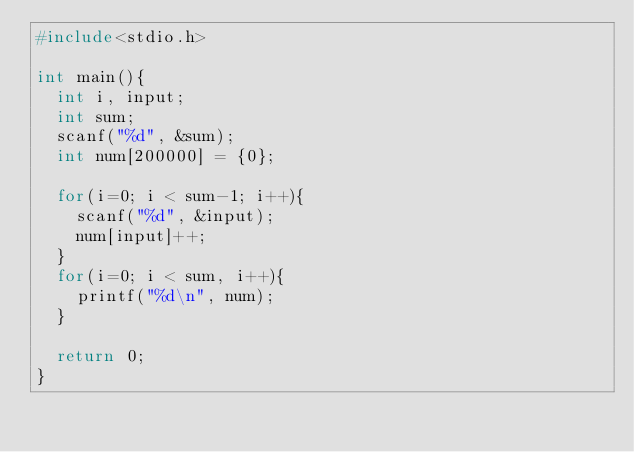Convert code to text. <code><loc_0><loc_0><loc_500><loc_500><_C_>#include<stdio.h>
 
int main(){
  int i, input;
  int sum;
  scanf("%d", &sum);
  int num[200000] = {0};
  
  for(i=0; i < sum-1; i++){
    scanf("%d", &input);
    num[input]++;
  }
  for(i=0; i < sum, i++){
    printf("%d\n", num);
  }
  
  return 0;
}</code> 